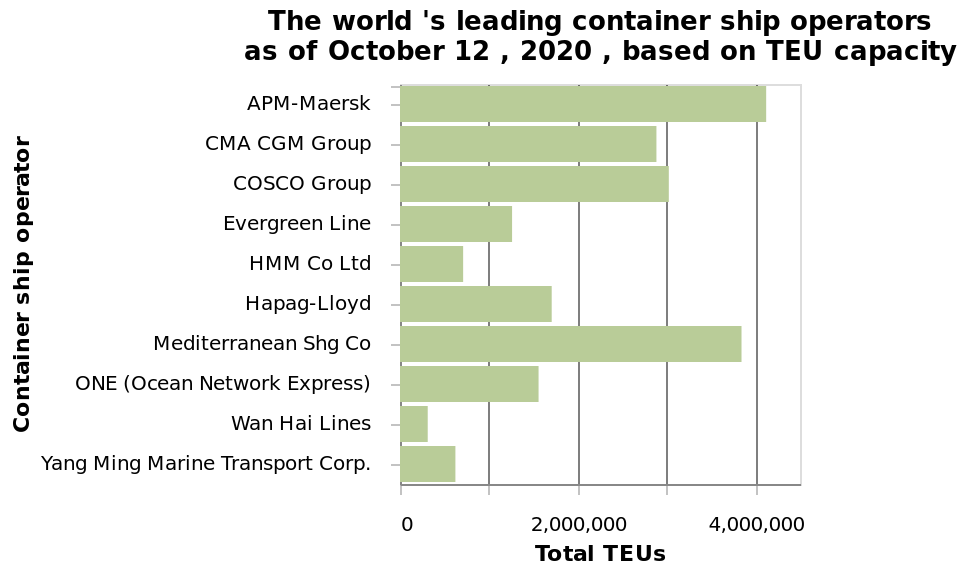<image>
Which container shipping company has the highest number of ships as of October 12, 2020?  APM-Maersk Which company is the third in the ranking as a container ship operator? Wan Hai Lines is the third in the ranking as a container ship operator. 